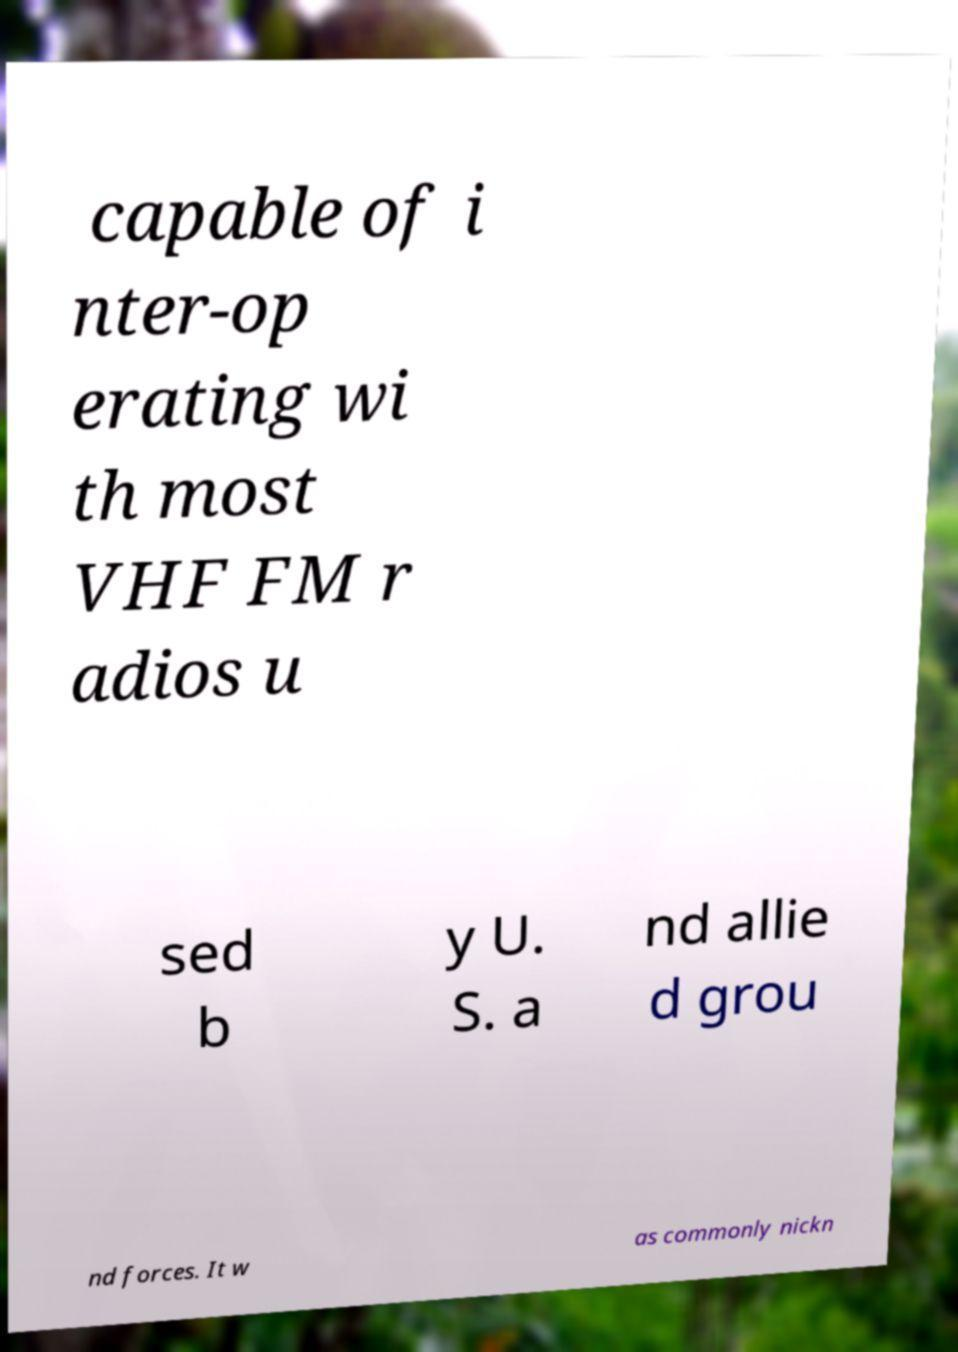Could you assist in decoding the text presented in this image and type it out clearly? capable of i nter-op erating wi th most VHF FM r adios u sed b y U. S. a nd allie d grou nd forces. It w as commonly nickn 